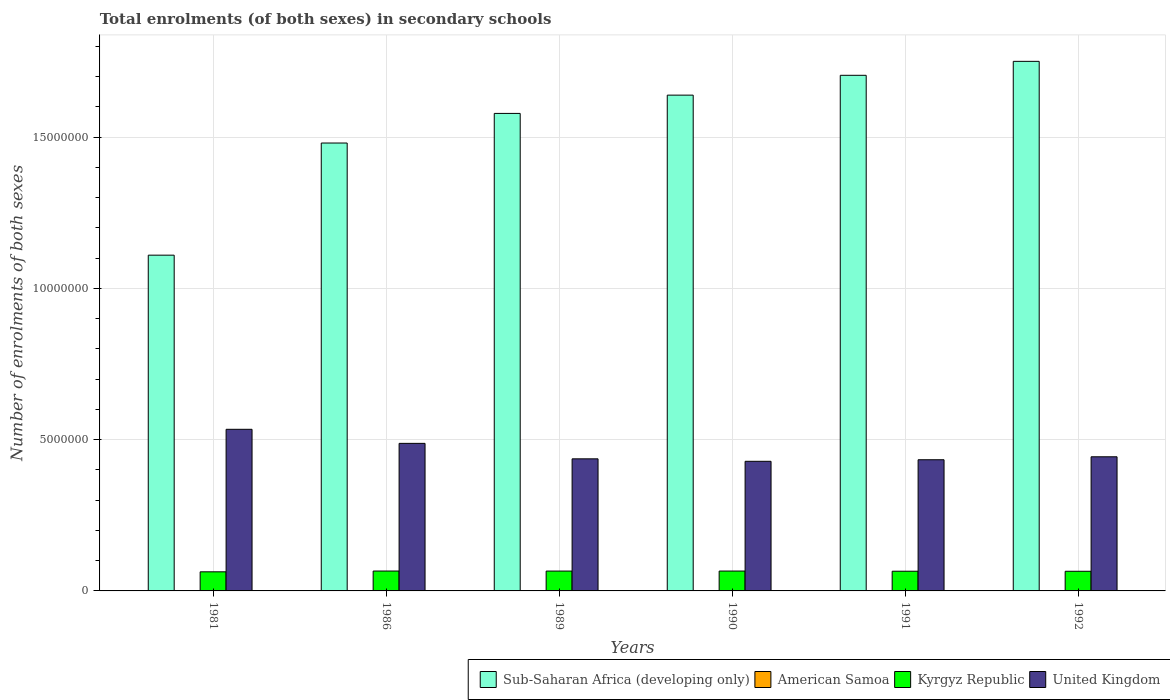How many different coloured bars are there?
Your response must be concise. 4. How many groups of bars are there?
Your answer should be compact. 6. Are the number of bars on each tick of the X-axis equal?
Provide a short and direct response. Yes. What is the label of the 2nd group of bars from the left?
Your answer should be very brief. 1986. What is the number of enrolments in secondary schools in Sub-Saharan Africa (developing only) in 1981?
Offer a terse response. 1.11e+07. Across all years, what is the maximum number of enrolments in secondary schools in Sub-Saharan Africa (developing only)?
Your answer should be compact. 1.75e+07. Across all years, what is the minimum number of enrolments in secondary schools in United Kingdom?
Give a very brief answer. 4.28e+06. What is the total number of enrolments in secondary schools in United Kingdom in the graph?
Make the answer very short. 2.76e+07. What is the difference between the number of enrolments in secondary schools in Kyrgyz Republic in 1981 and that in 1986?
Ensure brevity in your answer.  -2.59e+04. What is the difference between the number of enrolments in secondary schools in Sub-Saharan Africa (developing only) in 1981 and the number of enrolments in secondary schools in United Kingdom in 1990?
Offer a terse response. 6.81e+06. What is the average number of enrolments in secondary schools in American Samoa per year?
Your response must be concise. 3387. In the year 1986, what is the difference between the number of enrolments in secondary schools in American Samoa and number of enrolments in secondary schools in Sub-Saharan Africa (developing only)?
Your answer should be very brief. -1.48e+07. In how many years, is the number of enrolments in secondary schools in Sub-Saharan Africa (developing only) greater than 13000000?
Provide a succinct answer. 5. What is the ratio of the number of enrolments in secondary schools in American Samoa in 1981 to that in 1991?
Make the answer very short. 0.84. Is the difference between the number of enrolments in secondary schools in American Samoa in 1990 and 1991 greater than the difference between the number of enrolments in secondary schools in Sub-Saharan Africa (developing only) in 1990 and 1991?
Make the answer very short. Yes. What is the difference between the highest and the second highest number of enrolments in secondary schools in Kyrgyz Republic?
Provide a succinct answer. 900. What is the difference between the highest and the lowest number of enrolments in secondary schools in American Samoa?
Provide a succinct answer. 643. In how many years, is the number of enrolments in secondary schools in Sub-Saharan Africa (developing only) greater than the average number of enrolments in secondary schools in Sub-Saharan Africa (developing only) taken over all years?
Ensure brevity in your answer.  4. Is the sum of the number of enrolments in secondary schools in United Kingdom in 1986 and 1992 greater than the maximum number of enrolments in secondary schools in American Samoa across all years?
Your answer should be compact. Yes. What does the 3rd bar from the right in 1986 represents?
Keep it short and to the point. American Samoa. Is it the case that in every year, the sum of the number of enrolments in secondary schools in Kyrgyz Republic and number of enrolments in secondary schools in Sub-Saharan Africa (developing only) is greater than the number of enrolments in secondary schools in American Samoa?
Keep it short and to the point. Yes. How many bars are there?
Make the answer very short. 24. Are all the bars in the graph horizontal?
Keep it short and to the point. No. Are the values on the major ticks of Y-axis written in scientific E-notation?
Ensure brevity in your answer.  No. How are the legend labels stacked?
Your answer should be compact. Horizontal. What is the title of the graph?
Give a very brief answer. Total enrolments (of both sexes) in secondary schools. What is the label or title of the X-axis?
Offer a terse response. Years. What is the label or title of the Y-axis?
Provide a succinct answer. Number of enrolments of both sexes. What is the Number of enrolments of both sexes in Sub-Saharan Africa (developing only) in 1981?
Your response must be concise. 1.11e+07. What is the Number of enrolments of both sexes in American Samoa in 1981?
Keep it short and to the point. 3000. What is the Number of enrolments of both sexes of Kyrgyz Republic in 1981?
Provide a succinct answer. 6.31e+05. What is the Number of enrolments of both sexes of United Kingdom in 1981?
Keep it short and to the point. 5.34e+06. What is the Number of enrolments of both sexes of Sub-Saharan Africa (developing only) in 1986?
Ensure brevity in your answer.  1.48e+07. What is the Number of enrolments of both sexes of American Samoa in 1986?
Offer a very short reply. 3342. What is the Number of enrolments of both sexes in Kyrgyz Republic in 1986?
Provide a succinct answer. 6.57e+05. What is the Number of enrolments of both sexes in United Kingdom in 1986?
Your answer should be compact. 4.88e+06. What is the Number of enrolments of both sexes in Sub-Saharan Africa (developing only) in 1989?
Your answer should be compact. 1.58e+07. What is the Number of enrolments of both sexes of American Samoa in 1989?
Keep it short and to the point. 3335. What is the Number of enrolments of both sexes of Kyrgyz Republic in 1989?
Provide a succinct answer. 6.56e+05. What is the Number of enrolments of both sexes of United Kingdom in 1989?
Offer a very short reply. 4.37e+06. What is the Number of enrolments of both sexes in Sub-Saharan Africa (developing only) in 1990?
Make the answer very short. 1.64e+07. What is the Number of enrolments of both sexes of American Samoa in 1990?
Your response must be concise. 3437. What is the Number of enrolments of both sexes of Kyrgyz Republic in 1990?
Offer a very short reply. 6.56e+05. What is the Number of enrolments of both sexes in United Kingdom in 1990?
Provide a succinct answer. 4.28e+06. What is the Number of enrolments of both sexes of Sub-Saharan Africa (developing only) in 1991?
Your answer should be very brief. 1.70e+07. What is the Number of enrolments of both sexes of American Samoa in 1991?
Your answer should be very brief. 3565. What is the Number of enrolments of both sexes of Kyrgyz Republic in 1991?
Offer a very short reply. 6.51e+05. What is the Number of enrolments of both sexes in United Kingdom in 1991?
Offer a terse response. 4.34e+06. What is the Number of enrolments of both sexes in Sub-Saharan Africa (developing only) in 1992?
Your response must be concise. 1.75e+07. What is the Number of enrolments of both sexes of American Samoa in 1992?
Offer a very short reply. 3643. What is the Number of enrolments of both sexes in Kyrgyz Republic in 1992?
Make the answer very short. 6.50e+05. What is the Number of enrolments of both sexes in United Kingdom in 1992?
Give a very brief answer. 4.43e+06. Across all years, what is the maximum Number of enrolments of both sexes in Sub-Saharan Africa (developing only)?
Give a very brief answer. 1.75e+07. Across all years, what is the maximum Number of enrolments of both sexes in American Samoa?
Offer a very short reply. 3643. Across all years, what is the maximum Number of enrolments of both sexes in Kyrgyz Republic?
Make the answer very short. 6.57e+05. Across all years, what is the maximum Number of enrolments of both sexes of United Kingdom?
Provide a succinct answer. 5.34e+06. Across all years, what is the minimum Number of enrolments of both sexes in Sub-Saharan Africa (developing only)?
Your answer should be very brief. 1.11e+07. Across all years, what is the minimum Number of enrolments of both sexes of American Samoa?
Provide a succinct answer. 3000. Across all years, what is the minimum Number of enrolments of both sexes of Kyrgyz Republic?
Offer a very short reply. 6.31e+05. Across all years, what is the minimum Number of enrolments of both sexes in United Kingdom?
Your answer should be very brief. 4.28e+06. What is the total Number of enrolments of both sexes of Sub-Saharan Africa (developing only) in the graph?
Your answer should be compact. 9.26e+07. What is the total Number of enrolments of both sexes of American Samoa in the graph?
Offer a very short reply. 2.03e+04. What is the total Number of enrolments of both sexes of Kyrgyz Republic in the graph?
Keep it short and to the point. 3.90e+06. What is the total Number of enrolments of both sexes of United Kingdom in the graph?
Your response must be concise. 2.76e+07. What is the difference between the Number of enrolments of both sexes of Sub-Saharan Africa (developing only) in 1981 and that in 1986?
Offer a very short reply. -3.71e+06. What is the difference between the Number of enrolments of both sexes of American Samoa in 1981 and that in 1986?
Offer a very short reply. -342. What is the difference between the Number of enrolments of both sexes of Kyrgyz Republic in 1981 and that in 1986?
Offer a very short reply. -2.59e+04. What is the difference between the Number of enrolments of both sexes in United Kingdom in 1981 and that in 1986?
Provide a succinct answer. 4.65e+05. What is the difference between the Number of enrolments of both sexes of Sub-Saharan Africa (developing only) in 1981 and that in 1989?
Offer a terse response. -4.69e+06. What is the difference between the Number of enrolments of both sexes in American Samoa in 1981 and that in 1989?
Ensure brevity in your answer.  -335. What is the difference between the Number of enrolments of both sexes of Kyrgyz Republic in 1981 and that in 1989?
Give a very brief answer. -2.47e+04. What is the difference between the Number of enrolments of both sexes of United Kingdom in 1981 and that in 1989?
Give a very brief answer. 9.76e+05. What is the difference between the Number of enrolments of both sexes in Sub-Saharan Africa (developing only) in 1981 and that in 1990?
Your answer should be compact. -5.29e+06. What is the difference between the Number of enrolments of both sexes in American Samoa in 1981 and that in 1990?
Offer a terse response. -437. What is the difference between the Number of enrolments of both sexes in Kyrgyz Republic in 1981 and that in 1990?
Give a very brief answer. -2.50e+04. What is the difference between the Number of enrolments of both sexes of United Kingdom in 1981 and that in 1990?
Offer a terse response. 1.06e+06. What is the difference between the Number of enrolments of both sexes in Sub-Saharan Africa (developing only) in 1981 and that in 1991?
Offer a very short reply. -5.94e+06. What is the difference between the Number of enrolments of both sexes in American Samoa in 1981 and that in 1991?
Your answer should be compact. -565. What is the difference between the Number of enrolments of both sexes in Kyrgyz Republic in 1981 and that in 1991?
Offer a terse response. -1.98e+04. What is the difference between the Number of enrolments of both sexes in United Kingdom in 1981 and that in 1991?
Make the answer very short. 1.01e+06. What is the difference between the Number of enrolments of both sexes of Sub-Saharan Africa (developing only) in 1981 and that in 1992?
Ensure brevity in your answer.  -6.41e+06. What is the difference between the Number of enrolments of both sexes of American Samoa in 1981 and that in 1992?
Your answer should be compact. -643. What is the difference between the Number of enrolments of both sexes in Kyrgyz Republic in 1981 and that in 1992?
Ensure brevity in your answer.  -1.82e+04. What is the difference between the Number of enrolments of both sexes of United Kingdom in 1981 and that in 1992?
Your answer should be compact. 9.08e+05. What is the difference between the Number of enrolments of both sexes of Sub-Saharan Africa (developing only) in 1986 and that in 1989?
Give a very brief answer. -9.79e+05. What is the difference between the Number of enrolments of both sexes in American Samoa in 1986 and that in 1989?
Ensure brevity in your answer.  7. What is the difference between the Number of enrolments of both sexes of Kyrgyz Republic in 1986 and that in 1989?
Make the answer very short. 1200. What is the difference between the Number of enrolments of both sexes of United Kingdom in 1986 and that in 1989?
Ensure brevity in your answer.  5.11e+05. What is the difference between the Number of enrolments of both sexes of Sub-Saharan Africa (developing only) in 1986 and that in 1990?
Your response must be concise. -1.58e+06. What is the difference between the Number of enrolments of both sexes in American Samoa in 1986 and that in 1990?
Keep it short and to the point. -95. What is the difference between the Number of enrolments of both sexes of Kyrgyz Republic in 1986 and that in 1990?
Give a very brief answer. 900. What is the difference between the Number of enrolments of both sexes in United Kingdom in 1986 and that in 1990?
Offer a very short reply. 5.93e+05. What is the difference between the Number of enrolments of both sexes of Sub-Saharan Africa (developing only) in 1986 and that in 1991?
Give a very brief answer. -2.24e+06. What is the difference between the Number of enrolments of both sexes in American Samoa in 1986 and that in 1991?
Offer a terse response. -223. What is the difference between the Number of enrolments of both sexes of Kyrgyz Republic in 1986 and that in 1991?
Make the answer very short. 6100. What is the difference between the Number of enrolments of both sexes of United Kingdom in 1986 and that in 1991?
Offer a terse response. 5.41e+05. What is the difference between the Number of enrolments of both sexes in Sub-Saharan Africa (developing only) in 1986 and that in 1992?
Your answer should be compact. -2.70e+06. What is the difference between the Number of enrolments of both sexes of American Samoa in 1986 and that in 1992?
Provide a succinct answer. -301. What is the difference between the Number of enrolments of both sexes in Kyrgyz Republic in 1986 and that in 1992?
Keep it short and to the point. 7700. What is the difference between the Number of enrolments of both sexes of United Kingdom in 1986 and that in 1992?
Offer a very short reply. 4.44e+05. What is the difference between the Number of enrolments of both sexes of Sub-Saharan Africa (developing only) in 1989 and that in 1990?
Make the answer very short. -6.04e+05. What is the difference between the Number of enrolments of both sexes in American Samoa in 1989 and that in 1990?
Keep it short and to the point. -102. What is the difference between the Number of enrolments of both sexes in Kyrgyz Republic in 1989 and that in 1990?
Ensure brevity in your answer.  -300. What is the difference between the Number of enrolments of both sexes in United Kingdom in 1989 and that in 1990?
Keep it short and to the point. 8.19e+04. What is the difference between the Number of enrolments of both sexes of Sub-Saharan Africa (developing only) in 1989 and that in 1991?
Provide a short and direct response. -1.26e+06. What is the difference between the Number of enrolments of both sexes in American Samoa in 1989 and that in 1991?
Offer a terse response. -230. What is the difference between the Number of enrolments of both sexes of Kyrgyz Republic in 1989 and that in 1991?
Make the answer very short. 4900. What is the difference between the Number of enrolments of both sexes of United Kingdom in 1989 and that in 1991?
Ensure brevity in your answer.  3.03e+04. What is the difference between the Number of enrolments of both sexes of Sub-Saharan Africa (developing only) in 1989 and that in 1992?
Offer a very short reply. -1.72e+06. What is the difference between the Number of enrolments of both sexes of American Samoa in 1989 and that in 1992?
Provide a succinct answer. -308. What is the difference between the Number of enrolments of both sexes in Kyrgyz Republic in 1989 and that in 1992?
Ensure brevity in your answer.  6500. What is the difference between the Number of enrolments of both sexes of United Kingdom in 1989 and that in 1992?
Provide a short and direct response. -6.76e+04. What is the difference between the Number of enrolments of both sexes of Sub-Saharan Africa (developing only) in 1990 and that in 1991?
Provide a succinct answer. -6.55e+05. What is the difference between the Number of enrolments of both sexes in American Samoa in 1990 and that in 1991?
Your answer should be very brief. -128. What is the difference between the Number of enrolments of both sexes in Kyrgyz Republic in 1990 and that in 1991?
Ensure brevity in your answer.  5200. What is the difference between the Number of enrolments of both sexes in United Kingdom in 1990 and that in 1991?
Keep it short and to the point. -5.16e+04. What is the difference between the Number of enrolments of both sexes in Sub-Saharan Africa (developing only) in 1990 and that in 1992?
Offer a very short reply. -1.12e+06. What is the difference between the Number of enrolments of both sexes of American Samoa in 1990 and that in 1992?
Your answer should be very brief. -206. What is the difference between the Number of enrolments of both sexes in Kyrgyz Republic in 1990 and that in 1992?
Your response must be concise. 6800. What is the difference between the Number of enrolments of both sexes in United Kingdom in 1990 and that in 1992?
Provide a short and direct response. -1.50e+05. What is the difference between the Number of enrolments of both sexes in Sub-Saharan Africa (developing only) in 1991 and that in 1992?
Ensure brevity in your answer.  -4.61e+05. What is the difference between the Number of enrolments of both sexes in American Samoa in 1991 and that in 1992?
Provide a short and direct response. -78. What is the difference between the Number of enrolments of both sexes of Kyrgyz Republic in 1991 and that in 1992?
Keep it short and to the point. 1600. What is the difference between the Number of enrolments of both sexes of United Kingdom in 1991 and that in 1992?
Provide a succinct answer. -9.79e+04. What is the difference between the Number of enrolments of both sexes in Sub-Saharan Africa (developing only) in 1981 and the Number of enrolments of both sexes in American Samoa in 1986?
Your answer should be compact. 1.11e+07. What is the difference between the Number of enrolments of both sexes in Sub-Saharan Africa (developing only) in 1981 and the Number of enrolments of both sexes in Kyrgyz Republic in 1986?
Provide a succinct answer. 1.04e+07. What is the difference between the Number of enrolments of both sexes in Sub-Saharan Africa (developing only) in 1981 and the Number of enrolments of both sexes in United Kingdom in 1986?
Give a very brief answer. 6.22e+06. What is the difference between the Number of enrolments of both sexes in American Samoa in 1981 and the Number of enrolments of both sexes in Kyrgyz Republic in 1986?
Your answer should be very brief. -6.54e+05. What is the difference between the Number of enrolments of both sexes of American Samoa in 1981 and the Number of enrolments of both sexes of United Kingdom in 1986?
Keep it short and to the point. -4.87e+06. What is the difference between the Number of enrolments of both sexes of Kyrgyz Republic in 1981 and the Number of enrolments of both sexes of United Kingdom in 1986?
Offer a terse response. -4.25e+06. What is the difference between the Number of enrolments of both sexes in Sub-Saharan Africa (developing only) in 1981 and the Number of enrolments of both sexes in American Samoa in 1989?
Your answer should be compact. 1.11e+07. What is the difference between the Number of enrolments of both sexes in Sub-Saharan Africa (developing only) in 1981 and the Number of enrolments of both sexes in Kyrgyz Republic in 1989?
Give a very brief answer. 1.04e+07. What is the difference between the Number of enrolments of both sexes in Sub-Saharan Africa (developing only) in 1981 and the Number of enrolments of both sexes in United Kingdom in 1989?
Provide a short and direct response. 6.73e+06. What is the difference between the Number of enrolments of both sexes in American Samoa in 1981 and the Number of enrolments of both sexes in Kyrgyz Republic in 1989?
Make the answer very short. -6.53e+05. What is the difference between the Number of enrolments of both sexes in American Samoa in 1981 and the Number of enrolments of both sexes in United Kingdom in 1989?
Provide a short and direct response. -4.36e+06. What is the difference between the Number of enrolments of both sexes in Kyrgyz Republic in 1981 and the Number of enrolments of both sexes in United Kingdom in 1989?
Offer a very short reply. -3.73e+06. What is the difference between the Number of enrolments of both sexes in Sub-Saharan Africa (developing only) in 1981 and the Number of enrolments of both sexes in American Samoa in 1990?
Provide a succinct answer. 1.11e+07. What is the difference between the Number of enrolments of both sexes of Sub-Saharan Africa (developing only) in 1981 and the Number of enrolments of both sexes of Kyrgyz Republic in 1990?
Your answer should be compact. 1.04e+07. What is the difference between the Number of enrolments of both sexes of Sub-Saharan Africa (developing only) in 1981 and the Number of enrolments of both sexes of United Kingdom in 1990?
Provide a short and direct response. 6.81e+06. What is the difference between the Number of enrolments of both sexes of American Samoa in 1981 and the Number of enrolments of both sexes of Kyrgyz Republic in 1990?
Offer a very short reply. -6.53e+05. What is the difference between the Number of enrolments of both sexes of American Samoa in 1981 and the Number of enrolments of both sexes of United Kingdom in 1990?
Your answer should be compact. -4.28e+06. What is the difference between the Number of enrolments of both sexes in Kyrgyz Republic in 1981 and the Number of enrolments of both sexes in United Kingdom in 1990?
Offer a very short reply. -3.65e+06. What is the difference between the Number of enrolments of both sexes in Sub-Saharan Africa (developing only) in 1981 and the Number of enrolments of both sexes in American Samoa in 1991?
Give a very brief answer. 1.11e+07. What is the difference between the Number of enrolments of both sexes in Sub-Saharan Africa (developing only) in 1981 and the Number of enrolments of both sexes in Kyrgyz Republic in 1991?
Your answer should be compact. 1.04e+07. What is the difference between the Number of enrolments of both sexes in Sub-Saharan Africa (developing only) in 1981 and the Number of enrolments of both sexes in United Kingdom in 1991?
Make the answer very short. 6.76e+06. What is the difference between the Number of enrolments of both sexes of American Samoa in 1981 and the Number of enrolments of both sexes of Kyrgyz Republic in 1991?
Your response must be concise. -6.48e+05. What is the difference between the Number of enrolments of both sexes of American Samoa in 1981 and the Number of enrolments of both sexes of United Kingdom in 1991?
Offer a very short reply. -4.33e+06. What is the difference between the Number of enrolments of both sexes of Kyrgyz Republic in 1981 and the Number of enrolments of both sexes of United Kingdom in 1991?
Offer a very short reply. -3.70e+06. What is the difference between the Number of enrolments of both sexes in Sub-Saharan Africa (developing only) in 1981 and the Number of enrolments of both sexes in American Samoa in 1992?
Your response must be concise. 1.11e+07. What is the difference between the Number of enrolments of both sexes in Sub-Saharan Africa (developing only) in 1981 and the Number of enrolments of both sexes in Kyrgyz Republic in 1992?
Your response must be concise. 1.04e+07. What is the difference between the Number of enrolments of both sexes in Sub-Saharan Africa (developing only) in 1981 and the Number of enrolments of both sexes in United Kingdom in 1992?
Make the answer very short. 6.66e+06. What is the difference between the Number of enrolments of both sexes in American Samoa in 1981 and the Number of enrolments of both sexes in Kyrgyz Republic in 1992?
Provide a short and direct response. -6.47e+05. What is the difference between the Number of enrolments of both sexes of American Samoa in 1981 and the Number of enrolments of both sexes of United Kingdom in 1992?
Offer a terse response. -4.43e+06. What is the difference between the Number of enrolments of both sexes of Kyrgyz Republic in 1981 and the Number of enrolments of both sexes of United Kingdom in 1992?
Provide a succinct answer. -3.80e+06. What is the difference between the Number of enrolments of both sexes in Sub-Saharan Africa (developing only) in 1986 and the Number of enrolments of both sexes in American Samoa in 1989?
Provide a succinct answer. 1.48e+07. What is the difference between the Number of enrolments of both sexes of Sub-Saharan Africa (developing only) in 1986 and the Number of enrolments of both sexes of Kyrgyz Republic in 1989?
Your answer should be very brief. 1.41e+07. What is the difference between the Number of enrolments of both sexes in Sub-Saharan Africa (developing only) in 1986 and the Number of enrolments of both sexes in United Kingdom in 1989?
Provide a short and direct response. 1.04e+07. What is the difference between the Number of enrolments of both sexes in American Samoa in 1986 and the Number of enrolments of both sexes in Kyrgyz Republic in 1989?
Ensure brevity in your answer.  -6.53e+05. What is the difference between the Number of enrolments of both sexes of American Samoa in 1986 and the Number of enrolments of both sexes of United Kingdom in 1989?
Ensure brevity in your answer.  -4.36e+06. What is the difference between the Number of enrolments of both sexes of Kyrgyz Republic in 1986 and the Number of enrolments of both sexes of United Kingdom in 1989?
Your response must be concise. -3.71e+06. What is the difference between the Number of enrolments of both sexes of Sub-Saharan Africa (developing only) in 1986 and the Number of enrolments of both sexes of American Samoa in 1990?
Provide a succinct answer. 1.48e+07. What is the difference between the Number of enrolments of both sexes of Sub-Saharan Africa (developing only) in 1986 and the Number of enrolments of both sexes of Kyrgyz Republic in 1990?
Offer a terse response. 1.41e+07. What is the difference between the Number of enrolments of both sexes in Sub-Saharan Africa (developing only) in 1986 and the Number of enrolments of both sexes in United Kingdom in 1990?
Keep it short and to the point. 1.05e+07. What is the difference between the Number of enrolments of both sexes of American Samoa in 1986 and the Number of enrolments of both sexes of Kyrgyz Republic in 1990?
Give a very brief answer. -6.53e+05. What is the difference between the Number of enrolments of both sexes in American Samoa in 1986 and the Number of enrolments of both sexes in United Kingdom in 1990?
Ensure brevity in your answer.  -4.28e+06. What is the difference between the Number of enrolments of both sexes in Kyrgyz Republic in 1986 and the Number of enrolments of both sexes in United Kingdom in 1990?
Make the answer very short. -3.63e+06. What is the difference between the Number of enrolments of both sexes in Sub-Saharan Africa (developing only) in 1986 and the Number of enrolments of both sexes in American Samoa in 1991?
Offer a terse response. 1.48e+07. What is the difference between the Number of enrolments of both sexes of Sub-Saharan Africa (developing only) in 1986 and the Number of enrolments of both sexes of Kyrgyz Republic in 1991?
Offer a terse response. 1.42e+07. What is the difference between the Number of enrolments of both sexes in Sub-Saharan Africa (developing only) in 1986 and the Number of enrolments of both sexes in United Kingdom in 1991?
Your response must be concise. 1.05e+07. What is the difference between the Number of enrolments of both sexes of American Samoa in 1986 and the Number of enrolments of both sexes of Kyrgyz Republic in 1991?
Ensure brevity in your answer.  -6.48e+05. What is the difference between the Number of enrolments of both sexes of American Samoa in 1986 and the Number of enrolments of both sexes of United Kingdom in 1991?
Keep it short and to the point. -4.33e+06. What is the difference between the Number of enrolments of both sexes in Kyrgyz Republic in 1986 and the Number of enrolments of both sexes in United Kingdom in 1991?
Your answer should be very brief. -3.68e+06. What is the difference between the Number of enrolments of both sexes in Sub-Saharan Africa (developing only) in 1986 and the Number of enrolments of both sexes in American Samoa in 1992?
Your response must be concise. 1.48e+07. What is the difference between the Number of enrolments of both sexes of Sub-Saharan Africa (developing only) in 1986 and the Number of enrolments of both sexes of Kyrgyz Republic in 1992?
Keep it short and to the point. 1.42e+07. What is the difference between the Number of enrolments of both sexes of Sub-Saharan Africa (developing only) in 1986 and the Number of enrolments of both sexes of United Kingdom in 1992?
Ensure brevity in your answer.  1.04e+07. What is the difference between the Number of enrolments of both sexes of American Samoa in 1986 and the Number of enrolments of both sexes of Kyrgyz Republic in 1992?
Provide a succinct answer. -6.46e+05. What is the difference between the Number of enrolments of both sexes in American Samoa in 1986 and the Number of enrolments of both sexes in United Kingdom in 1992?
Offer a terse response. -4.43e+06. What is the difference between the Number of enrolments of both sexes of Kyrgyz Republic in 1986 and the Number of enrolments of both sexes of United Kingdom in 1992?
Ensure brevity in your answer.  -3.78e+06. What is the difference between the Number of enrolments of both sexes in Sub-Saharan Africa (developing only) in 1989 and the Number of enrolments of both sexes in American Samoa in 1990?
Make the answer very short. 1.58e+07. What is the difference between the Number of enrolments of both sexes of Sub-Saharan Africa (developing only) in 1989 and the Number of enrolments of both sexes of Kyrgyz Republic in 1990?
Offer a terse response. 1.51e+07. What is the difference between the Number of enrolments of both sexes in Sub-Saharan Africa (developing only) in 1989 and the Number of enrolments of both sexes in United Kingdom in 1990?
Offer a very short reply. 1.15e+07. What is the difference between the Number of enrolments of both sexes in American Samoa in 1989 and the Number of enrolments of both sexes in Kyrgyz Republic in 1990?
Provide a short and direct response. -6.53e+05. What is the difference between the Number of enrolments of both sexes of American Samoa in 1989 and the Number of enrolments of both sexes of United Kingdom in 1990?
Your answer should be compact. -4.28e+06. What is the difference between the Number of enrolments of both sexes in Kyrgyz Republic in 1989 and the Number of enrolments of both sexes in United Kingdom in 1990?
Your response must be concise. -3.63e+06. What is the difference between the Number of enrolments of both sexes of Sub-Saharan Africa (developing only) in 1989 and the Number of enrolments of both sexes of American Samoa in 1991?
Make the answer very short. 1.58e+07. What is the difference between the Number of enrolments of both sexes of Sub-Saharan Africa (developing only) in 1989 and the Number of enrolments of both sexes of Kyrgyz Republic in 1991?
Make the answer very short. 1.51e+07. What is the difference between the Number of enrolments of both sexes in Sub-Saharan Africa (developing only) in 1989 and the Number of enrolments of both sexes in United Kingdom in 1991?
Ensure brevity in your answer.  1.14e+07. What is the difference between the Number of enrolments of both sexes of American Samoa in 1989 and the Number of enrolments of both sexes of Kyrgyz Republic in 1991?
Provide a succinct answer. -6.48e+05. What is the difference between the Number of enrolments of both sexes in American Samoa in 1989 and the Number of enrolments of both sexes in United Kingdom in 1991?
Provide a short and direct response. -4.33e+06. What is the difference between the Number of enrolments of both sexes in Kyrgyz Republic in 1989 and the Number of enrolments of both sexes in United Kingdom in 1991?
Your answer should be very brief. -3.68e+06. What is the difference between the Number of enrolments of both sexes of Sub-Saharan Africa (developing only) in 1989 and the Number of enrolments of both sexes of American Samoa in 1992?
Keep it short and to the point. 1.58e+07. What is the difference between the Number of enrolments of both sexes of Sub-Saharan Africa (developing only) in 1989 and the Number of enrolments of both sexes of Kyrgyz Republic in 1992?
Provide a short and direct response. 1.51e+07. What is the difference between the Number of enrolments of both sexes of Sub-Saharan Africa (developing only) in 1989 and the Number of enrolments of both sexes of United Kingdom in 1992?
Make the answer very short. 1.13e+07. What is the difference between the Number of enrolments of both sexes of American Samoa in 1989 and the Number of enrolments of both sexes of Kyrgyz Republic in 1992?
Your response must be concise. -6.46e+05. What is the difference between the Number of enrolments of both sexes in American Samoa in 1989 and the Number of enrolments of both sexes in United Kingdom in 1992?
Make the answer very short. -4.43e+06. What is the difference between the Number of enrolments of both sexes in Kyrgyz Republic in 1989 and the Number of enrolments of both sexes in United Kingdom in 1992?
Keep it short and to the point. -3.78e+06. What is the difference between the Number of enrolments of both sexes of Sub-Saharan Africa (developing only) in 1990 and the Number of enrolments of both sexes of American Samoa in 1991?
Offer a terse response. 1.64e+07. What is the difference between the Number of enrolments of both sexes in Sub-Saharan Africa (developing only) in 1990 and the Number of enrolments of both sexes in Kyrgyz Republic in 1991?
Make the answer very short. 1.57e+07. What is the difference between the Number of enrolments of both sexes in Sub-Saharan Africa (developing only) in 1990 and the Number of enrolments of both sexes in United Kingdom in 1991?
Provide a succinct answer. 1.21e+07. What is the difference between the Number of enrolments of both sexes of American Samoa in 1990 and the Number of enrolments of both sexes of Kyrgyz Republic in 1991?
Offer a very short reply. -6.48e+05. What is the difference between the Number of enrolments of both sexes of American Samoa in 1990 and the Number of enrolments of both sexes of United Kingdom in 1991?
Make the answer very short. -4.33e+06. What is the difference between the Number of enrolments of both sexes in Kyrgyz Republic in 1990 and the Number of enrolments of both sexes in United Kingdom in 1991?
Make the answer very short. -3.68e+06. What is the difference between the Number of enrolments of both sexes in Sub-Saharan Africa (developing only) in 1990 and the Number of enrolments of both sexes in American Samoa in 1992?
Provide a short and direct response. 1.64e+07. What is the difference between the Number of enrolments of both sexes in Sub-Saharan Africa (developing only) in 1990 and the Number of enrolments of both sexes in Kyrgyz Republic in 1992?
Keep it short and to the point. 1.57e+07. What is the difference between the Number of enrolments of both sexes of Sub-Saharan Africa (developing only) in 1990 and the Number of enrolments of both sexes of United Kingdom in 1992?
Your response must be concise. 1.20e+07. What is the difference between the Number of enrolments of both sexes of American Samoa in 1990 and the Number of enrolments of both sexes of Kyrgyz Republic in 1992?
Your answer should be compact. -6.46e+05. What is the difference between the Number of enrolments of both sexes of American Samoa in 1990 and the Number of enrolments of both sexes of United Kingdom in 1992?
Your response must be concise. -4.43e+06. What is the difference between the Number of enrolments of both sexes in Kyrgyz Republic in 1990 and the Number of enrolments of both sexes in United Kingdom in 1992?
Give a very brief answer. -3.78e+06. What is the difference between the Number of enrolments of both sexes of Sub-Saharan Africa (developing only) in 1991 and the Number of enrolments of both sexes of American Samoa in 1992?
Keep it short and to the point. 1.70e+07. What is the difference between the Number of enrolments of both sexes of Sub-Saharan Africa (developing only) in 1991 and the Number of enrolments of both sexes of Kyrgyz Republic in 1992?
Make the answer very short. 1.64e+07. What is the difference between the Number of enrolments of both sexes of Sub-Saharan Africa (developing only) in 1991 and the Number of enrolments of both sexes of United Kingdom in 1992?
Your response must be concise. 1.26e+07. What is the difference between the Number of enrolments of both sexes of American Samoa in 1991 and the Number of enrolments of both sexes of Kyrgyz Republic in 1992?
Your response must be concise. -6.46e+05. What is the difference between the Number of enrolments of both sexes in American Samoa in 1991 and the Number of enrolments of both sexes in United Kingdom in 1992?
Provide a succinct answer. -4.43e+06. What is the difference between the Number of enrolments of both sexes in Kyrgyz Republic in 1991 and the Number of enrolments of both sexes in United Kingdom in 1992?
Offer a very short reply. -3.78e+06. What is the average Number of enrolments of both sexes in Sub-Saharan Africa (developing only) per year?
Offer a terse response. 1.54e+07. What is the average Number of enrolments of both sexes of American Samoa per year?
Keep it short and to the point. 3387. What is the average Number of enrolments of both sexes in Kyrgyz Republic per year?
Offer a terse response. 6.50e+05. What is the average Number of enrolments of both sexes in United Kingdom per year?
Offer a terse response. 4.61e+06. In the year 1981, what is the difference between the Number of enrolments of both sexes of Sub-Saharan Africa (developing only) and Number of enrolments of both sexes of American Samoa?
Keep it short and to the point. 1.11e+07. In the year 1981, what is the difference between the Number of enrolments of both sexes of Sub-Saharan Africa (developing only) and Number of enrolments of both sexes of Kyrgyz Republic?
Make the answer very short. 1.05e+07. In the year 1981, what is the difference between the Number of enrolments of both sexes of Sub-Saharan Africa (developing only) and Number of enrolments of both sexes of United Kingdom?
Provide a succinct answer. 5.76e+06. In the year 1981, what is the difference between the Number of enrolments of both sexes of American Samoa and Number of enrolments of both sexes of Kyrgyz Republic?
Offer a very short reply. -6.28e+05. In the year 1981, what is the difference between the Number of enrolments of both sexes of American Samoa and Number of enrolments of both sexes of United Kingdom?
Offer a very short reply. -5.34e+06. In the year 1981, what is the difference between the Number of enrolments of both sexes of Kyrgyz Republic and Number of enrolments of both sexes of United Kingdom?
Give a very brief answer. -4.71e+06. In the year 1986, what is the difference between the Number of enrolments of both sexes of Sub-Saharan Africa (developing only) and Number of enrolments of both sexes of American Samoa?
Your response must be concise. 1.48e+07. In the year 1986, what is the difference between the Number of enrolments of both sexes of Sub-Saharan Africa (developing only) and Number of enrolments of both sexes of Kyrgyz Republic?
Keep it short and to the point. 1.41e+07. In the year 1986, what is the difference between the Number of enrolments of both sexes in Sub-Saharan Africa (developing only) and Number of enrolments of both sexes in United Kingdom?
Ensure brevity in your answer.  9.93e+06. In the year 1986, what is the difference between the Number of enrolments of both sexes of American Samoa and Number of enrolments of both sexes of Kyrgyz Republic?
Ensure brevity in your answer.  -6.54e+05. In the year 1986, what is the difference between the Number of enrolments of both sexes of American Samoa and Number of enrolments of both sexes of United Kingdom?
Your answer should be compact. -4.87e+06. In the year 1986, what is the difference between the Number of enrolments of both sexes of Kyrgyz Republic and Number of enrolments of both sexes of United Kingdom?
Your answer should be compact. -4.22e+06. In the year 1989, what is the difference between the Number of enrolments of both sexes in Sub-Saharan Africa (developing only) and Number of enrolments of both sexes in American Samoa?
Offer a very short reply. 1.58e+07. In the year 1989, what is the difference between the Number of enrolments of both sexes of Sub-Saharan Africa (developing only) and Number of enrolments of both sexes of Kyrgyz Republic?
Your answer should be very brief. 1.51e+07. In the year 1989, what is the difference between the Number of enrolments of both sexes of Sub-Saharan Africa (developing only) and Number of enrolments of both sexes of United Kingdom?
Offer a very short reply. 1.14e+07. In the year 1989, what is the difference between the Number of enrolments of both sexes of American Samoa and Number of enrolments of both sexes of Kyrgyz Republic?
Ensure brevity in your answer.  -6.53e+05. In the year 1989, what is the difference between the Number of enrolments of both sexes of American Samoa and Number of enrolments of both sexes of United Kingdom?
Your response must be concise. -4.36e+06. In the year 1989, what is the difference between the Number of enrolments of both sexes of Kyrgyz Republic and Number of enrolments of both sexes of United Kingdom?
Your answer should be very brief. -3.71e+06. In the year 1990, what is the difference between the Number of enrolments of both sexes in Sub-Saharan Africa (developing only) and Number of enrolments of both sexes in American Samoa?
Ensure brevity in your answer.  1.64e+07. In the year 1990, what is the difference between the Number of enrolments of both sexes in Sub-Saharan Africa (developing only) and Number of enrolments of both sexes in Kyrgyz Republic?
Give a very brief answer. 1.57e+07. In the year 1990, what is the difference between the Number of enrolments of both sexes of Sub-Saharan Africa (developing only) and Number of enrolments of both sexes of United Kingdom?
Give a very brief answer. 1.21e+07. In the year 1990, what is the difference between the Number of enrolments of both sexes of American Samoa and Number of enrolments of both sexes of Kyrgyz Republic?
Offer a very short reply. -6.53e+05. In the year 1990, what is the difference between the Number of enrolments of both sexes in American Samoa and Number of enrolments of both sexes in United Kingdom?
Your answer should be very brief. -4.28e+06. In the year 1990, what is the difference between the Number of enrolments of both sexes of Kyrgyz Republic and Number of enrolments of both sexes of United Kingdom?
Ensure brevity in your answer.  -3.63e+06. In the year 1991, what is the difference between the Number of enrolments of both sexes in Sub-Saharan Africa (developing only) and Number of enrolments of both sexes in American Samoa?
Provide a short and direct response. 1.70e+07. In the year 1991, what is the difference between the Number of enrolments of both sexes of Sub-Saharan Africa (developing only) and Number of enrolments of both sexes of Kyrgyz Republic?
Offer a very short reply. 1.64e+07. In the year 1991, what is the difference between the Number of enrolments of both sexes in Sub-Saharan Africa (developing only) and Number of enrolments of both sexes in United Kingdom?
Your answer should be very brief. 1.27e+07. In the year 1991, what is the difference between the Number of enrolments of both sexes of American Samoa and Number of enrolments of both sexes of Kyrgyz Republic?
Offer a terse response. -6.48e+05. In the year 1991, what is the difference between the Number of enrolments of both sexes of American Samoa and Number of enrolments of both sexes of United Kingdom?
Give a very brief answer. -4.33e+06. In the year 1991, what is the difference between the Number of enrolments of both sexes in Kyrgyz Republic and Number of enrolments of both sexes in United Kingdom?
Make the answer very short. -3.68e+06. In the year 1992, what is the difference between the Number of enrolments of both sexes of Sub-Saharan Africa (developing only) and Number of enrolments of both sexes of American Samoa?
Ensure brevity in your answer.  1.75e+07. In the year 1992, what is the difference between the Number of enrolments of both sexes of Sub-Saharan Africa (developing only) and Number of enrolments of both sexes of Kyrgyz Republic?
Provide a short and direct response. 1.69e+07. In the year 1992, what is the difference between the Number of enrolments of both sexes in Sub-Saharan Africa (developing only) and Number of enrolments of both sexes in United Kingdom?
Your answer should be very brief. 1.31e+07. In the year 1992, what is the difference between the Number of enrolments of both sexes of American Samoa and Number of enrolments of both sexes of Kyrgyz Republic?
Provide a short and direct response. -6.46e+05. In the year 1992, what is the difference between the Number of enrolments of both sexes in American Samoa and Number of enrolments of both sexes in United Kingdom?
Make the answer very short. -4.43e+06. In the year 1992, what is the difference between the Number of enrolments of both sexes of Kyrgyz Republic and Number of enrolments of both sexes of United Kingdom?
Your answer should be compact. -3.78e+06. What is the ratio of the Number of enrolments of both sexes of Sub-Saharan Africa (developing only) in 1981 to that in 1986?
Ensure brevity in your answer.  0.75. What is the ratio of the Number of enrolments of both sexes in American Samoa in 1981 to that in 1986?
Provide a short and direct response. 0.9. What is the ratio of the Number of enrolments of both sexes of Kyrgyz Republic in 1981 to that in 1986?
Offer a very short reply. 0.96. What is the ratio of the Number of enrolments of both sexes of United Kingdom in 1981 to that in 1986?
Your answer should be compact. 1.1. What is the ratio of the Number of enrolments of both sexes in Sub-Saharan Africa (developing only) in 1981 to that in 1989?
Give a very brief answer. 0.7. What is the ratio of the Number of enrolments of both sexes of American Samoa in 1981 to that in 1989?
Ensure brevity in your answer.  0.9. What is the ratio of the Number of enrolments of both sexes of Kyrgyz Republic in 1981 to that in 1989?
Your answer should be compact. 0.96. What is the ratio of the Number of enrolments of both sexes of United Kingdom in 1981 to that in 1989?
Your answer should be compact. 1.22. What is the ratio of the Number of enrolments of both sexes of Sub-Saharan Africa (developing only) in 1981 to that in 1990?
Your answer should be very brief. 0.68. What is the ratio of the Number of enrolments of both sexes in American Samoa in 1981 to that in 1990?
Your response must be concise. 0.87. What is the ratio of the Number of enrolments of both sexes in Kyrgyz Republic in 1981 to that in 1990?
Make the answer very short. 0.96. What is the ratio of the Number of enrolments of both sexes in United Kingdom in 1981 to that in 1990?
Offer a very short reply. 1.25. What is the ratio of the Number of enrolments of both sexes of Sub-Saharan Africa (developing only) in 1981 to that in 1991?
Your answer should be compact. 0.65. What is the ratio of the Number of enrolments of both sexes in American Samoa in 1981 to that in 1991?
Provide a succinct answer. 0.84. What is the ratio of the Number of enrolments of both sexes of Kyrgyz Republic in 1981 to that in 1991?
Provide a succinct answer. 0.97. What is the ratio of the Number of enrolments of both sexes in United Kingdom in 1981 to that in 1991?
Make the answer very short. 1.23. What is the ratio of the Number of enrolments of both sexes of Sub-Saharan Africa (developing only) in 1981 to that in 1992?
Your answer should be very brief. 0.63. What is the ratio of the Number of enrolments of both sexes of American Samoa in 1981 to that in 1992?
Provide a succinct answer. 0.82. What is the ratio of the Number of enrolments of both sexes in Kyrgyz Republic in 1981 to that in 1992?
Make the answer very short. 0.97. What is the ratio of the Number of enrolments of both sexes of United Kingdom in 1981 to that in 1992?
Keep it short and to the point. 1.2. What is the ratio of the Number of enrolments of both sexes in Sub-Saharan Africa (developing only) in 1986 to that in 1989?
Offer a very short reply. 0.94. What is the ratio of the Number of enrolments of both sexes of American Samoa in 1986 to that in 1989?
Your response must be concise. 1. What is the ratio of the Number of enrolments of both sexes of Kyrgyz Republic in 1986 to that in 1989?
Ensure brevity in your answer.  1. What is the ratio of the Number of enrolments of both sexes of United Kingdom in 1986 to that in 1989?
Provide a succinct answer. 1.12. What is the ratio of the Number of enrolments of both sexes of Sub-Saharan Africa (developing only) in 1986 to that in 1990?
Your response must be concise. 0.9. What is the ratio of the Number of enrolments of both sexes in American Samoa in 1986 to that in 1990?
Provide a short and direct response. 0.97. What is the ratio of the Number of enrolments of both sexes of Kyrgyz Republic in 1986 to that in 1990?
Your answer should be compact. 1. What is the ratio of the Number of enrolments of both sexes in United Kingdom in 1986 to that in 1990?
Your response must be concise. 1.14. What is the ratio of the Number of enrolments of both sexes of Sub-Saharan Africa (developing only) in 1986 to that in 1991?
Provide a succinct answer. 0.87. What is the ratio of the Number of enrolments of both sexes of American Samoa in 1986 to that in 1991?
Your response must be concise. 0.94. What is the ratio of the Number of enrolments of both sexes in Kyrgyz Republic in 1986 to that in 1991?
Offer a terse response. 1.01. What is the ratio of the Number of enrolments of both sexes in United Kingdom in 1986 to that in 1991?
Make the answer very short. 1.12. What is the ratio of the Number of enrolments of both sexes of Sub-Saharan Africa (developing only) in 1986 to that in 1992?
Give a very brief answer. 0.85. What is the ratio of the Number of enrolments of both sexes of American Samoa in 1986 to that in 1992?
Your response must be concise. 0.92. What is the ratio of the Number of enrolments of both sexes in Kyrgyz Republic in 1986 to that in 1992?
Your response must be concise. 1.01. What is the ratio of the Number of enrolments of both sexes in Sub-Saharan Africa (developing only) in 1989 to that in 1990?
Offer a terse response. 0.96. What is the ratio of the Number of enrolments of both sexes in American Samoa in 1989 to that in 1990?
Your response must be concise. 0.97. What is the ratio of the Number of enrolments of both sexes of United Kingdom in 1989 to that in 1990?
Give a very brief answer. 1.02. What is the ratio of the Number of enrolments of both sexes of Sub-Saharan Africa (developing only) in 1989 to that in 1991?
Keep it short and to the point. 0.93. What is the ratio of the Number of enrolments of both sexes of American Samoa in 1989 to that in 1991?
Your answer should be very brief. 0.94. What is the ratio of the Number of enrolments of both sexes in Kyrgyz Republic in 1989 to that in 1991?
Give a very brief answer. 1.01. What is the ratio of the Number of enrolments of both sexes of United Kingdom in 1989 to that in 1991?
Your response must be concise. 1.01. What is the ratio of the Number of enrolments of both sexes of Sub-Saharan Africa (developing only) in 1989 to that in 1992?
Give a very brief answer. 0.9. What is the ratio of the Number of enrolments of both sexes of American Samoa in 1989 to that in 1992?
Ensure brevity in your answer.  0.92. What is the ratio of the Number of enrolments of both sexes of Kyrgyz Republic in 1989 to that in 1992?
Your answer should be very brief. 1.01. What is the ratio of the Number of enrolments of both sexes in Sub-Saharan Africa (developing only) in 1990 to that in 1991?
Keep it short and to the point. 0.96. What is the ratio of the Number of enrolments of both sexes in American Samoa in 1990 to that in 1991?
Make the answer very short. 0.96. What is the ratio of the Number of enrolments of both sexes in Kyrgyz Republic in 1990 to that in 1991?
Offer a very short reply. 1.01. What is the ratio of the Number of enrolments of both sexes of United Kingdom in 1990 to that in 1991?
Your answer should be compact. 0.99. What is the ratio of the Number of enrolments of both sexes of Sub-Saharan Africa (developing only) in 1990 to that in 1992?
Keep it short and to the point. 0.94. What is the ratio of the Number of enrolments of both sexes of American Samoa in 1990 to that in 1992?
Make the answer very short. 0.94. What is the ratio of the Number of enrolments of both sexes of Kyrgyz Republic in 1990 to that in 1992?
Make the answer very short. 1.01. What is the ratio of the Number of enrolments of both sexes in United Kingdom in 1990 to that in 1992?
Offer a terse response. 0.97. What is the ratio of the Number of enrolments of both sexes of Sub-Saharan Africa (developing only) in 1991 to that in 1992?
Provide a short and direct response. 0.97. What is the ratio of the Number of enrolments of both sexes in American Samoa in 1991 to that in 1992?
Your answer should be compact. 0.98. What is the ratio of the Number of enrolments of both sexes of Kyrgyz Republic in 1991 to that in 1992?
Offer a very short reply. 1. What is the ratio of the Number of enrolments of both sexes of United Kingdom in 1991 to that in 1992?
Ensure brevity in your answer.  0.98. What is the difference between the highest and the second highest Number of enrolments of both sexes in Sub-Saharan Africa (developing only)?
Provide a succinct answer. 4.61e+05. What is the difference between the highest and the second highest Number of enrolments of both sexes of Kyrgyz Republic?
Keep it short and to the point. 900. What is the difference between the highest and the second highest Number of enrolments of both sexes in United Kingdom?
Your response must be concise. 4.65e+05. What is the difference between the highest and the lowest Number of enrolments of both sexes in Sub-Saharan Africa (developing only)?
Offer a very short reply. 6.41e+06. What is the difference between the highest and the lowest Number of enrolments of both sexes in American Samoa?
Provide a short and direct response. 643. What is the difference between the highest and the lowest Number of enrolments of both sexes in Kyrgyz Republic?
Your response must be concise. 2.59e+04. What is the difference between the highest and the lowest Number of enrolments of both sexes of United Kingdom?
Your answer should be very brief. 1.06e+06. 